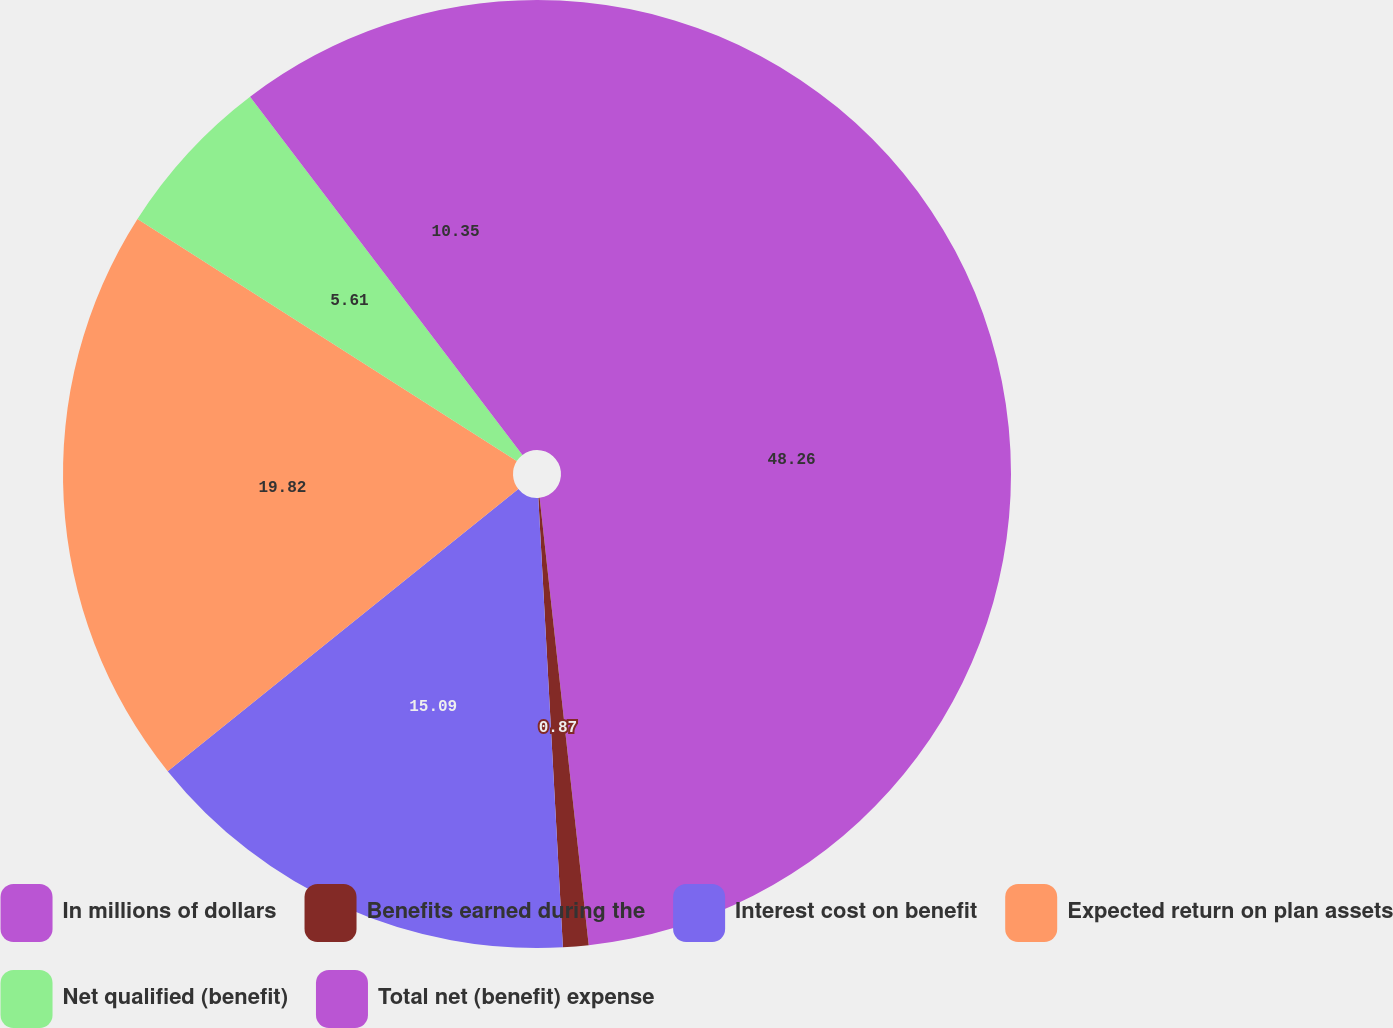Convert chart to OTSL. <chart><loc_0><loc_0><loc_500><loc_500><pie_chart><fcel>In millions of dollars<fcel>Benefits earned during the<fcel>Interest cost on benefit<fcel>Expected return on plan assets<fcel>Net qualified (benefit)<fcel>Total net (benefit) expense<nl><fcel>48.27%<fcel>0.87%<fcel>15.09%<fcel>19.83%<fcel>5.61%<fcel>10.35%<nl></chart> 